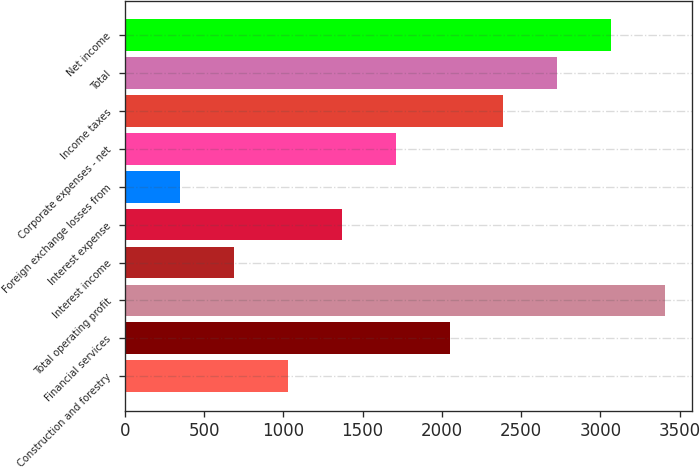Convert chart. <chart><loc_0><loc_0><loc_500><loc_500><bar_chart><fcel>Construction and forestry<fcel>Financial services<fcel>Total operating profit<fcel>Interest income<fcel>Interest expense<fcel>Foreign exchange losses from<fcel>Corporate expenses - net<fcel>Income taxes<fcel>Total<fcel>Net income<nl><fcel>1028.7<fcel>2048.4<fcel>3408<fcel>688.8<fcel>1368.6<fcel>348.9<fcel>1708.5<fcel>2388.3<fcel>2728.2<fcel>3068.1<nl></chart> 